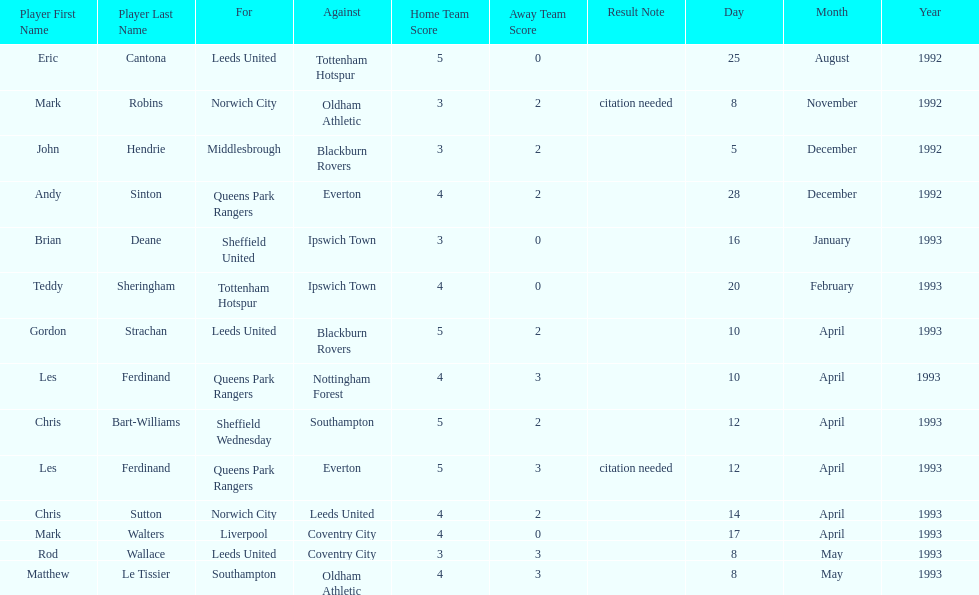Which player had the same result as mark robins? John Hendrie. 